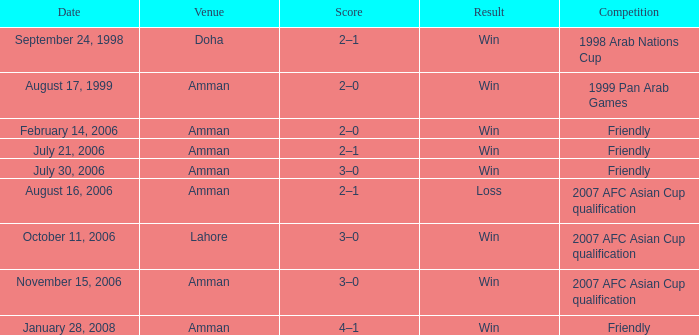What was the result of the friendly game at amman on february 14, 2006? 2–0. 